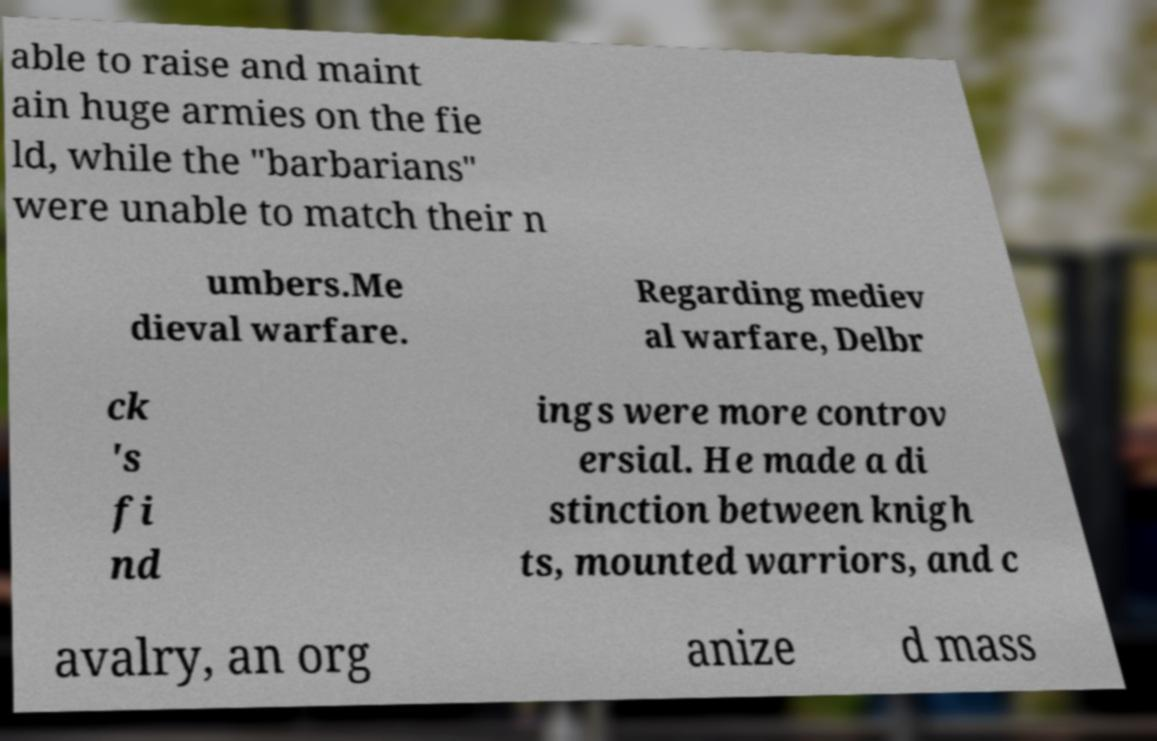Could you assist in decoding the text presented in this image and type it out clearly? able to raise and maint ain huge armies on the fie ld, while the "barbarians" were unable to match their n umbers.Me dieval warfare. Regarding mediev al warfare, Delbr ck 's fi nd ings were more controv ersial. He made a di stinction between knigh ts, mounted warriors, and c avalry, an org anize d mass 